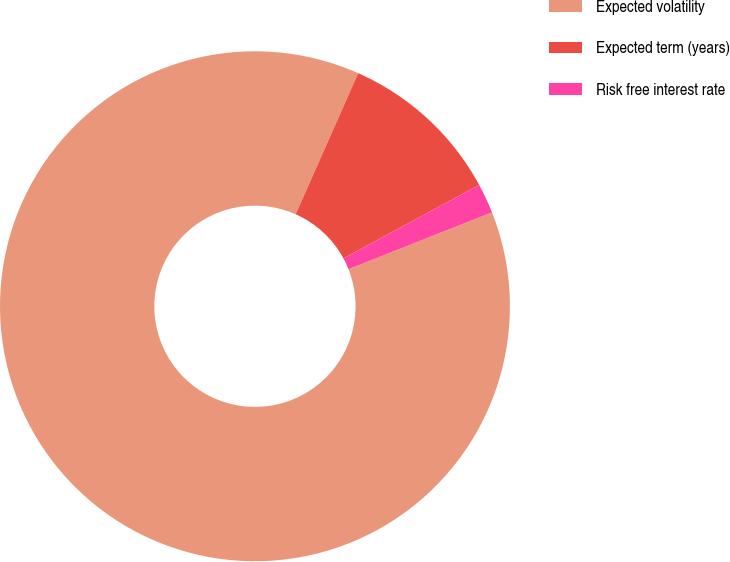Convert chart to OTSL. <chart><loc_0><loc_0><loc_500><loc_500><pie_chart><fcel>Expected volatility<fcel>Expected term (years)<fcel>Risk free interest rate<nl><fcel>87.63%<fcel>10.47%<fcel>1.89%<nl></chart> 